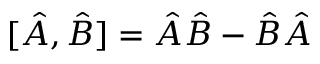Convert formula to latex. <formula><loc_0><loc_0><loc_500><loc_500>[ \hat { A } , \hat { B } ] = \hat { A } \hat { B } - \hat { B } \hat { A }</formula> 